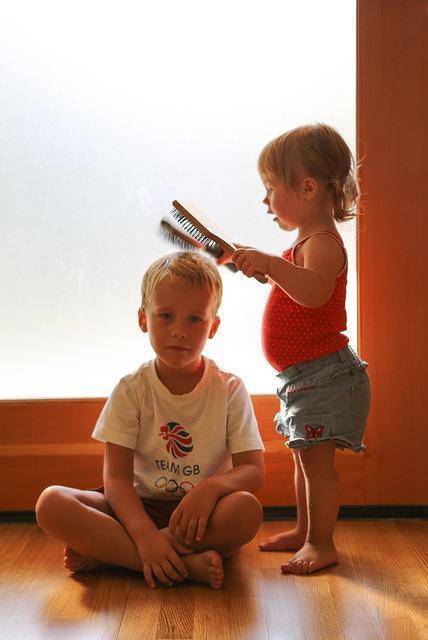How many people are in the picture?
Give a very brief answer. 2. 